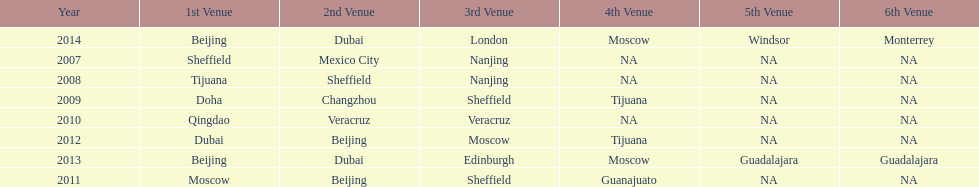What was the last year where tijuana was a venue? 2012. 